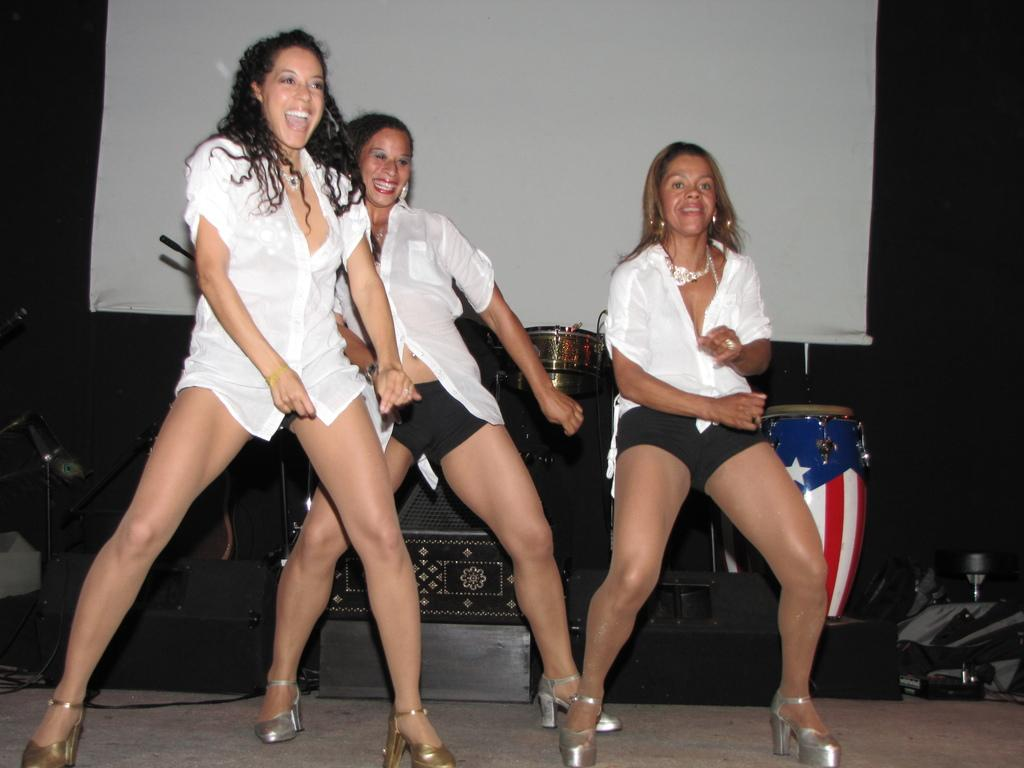How many women are present in the image? There are three women in the image. What are the women doing in the image? The women are dancing on a stage. Can you describe the movement of the women in the image? There is movement in their legs and hands. What else can be seen in the image besides the women? There are musical instruments and a white banner in the image. What type of building is visible in the image? There is no building visible in the image; it features three women dancing on a stage. What color is the skirt worn by the woman in the image? There is no woman wearing a skirt in the image; the women are wearing dance attire. 